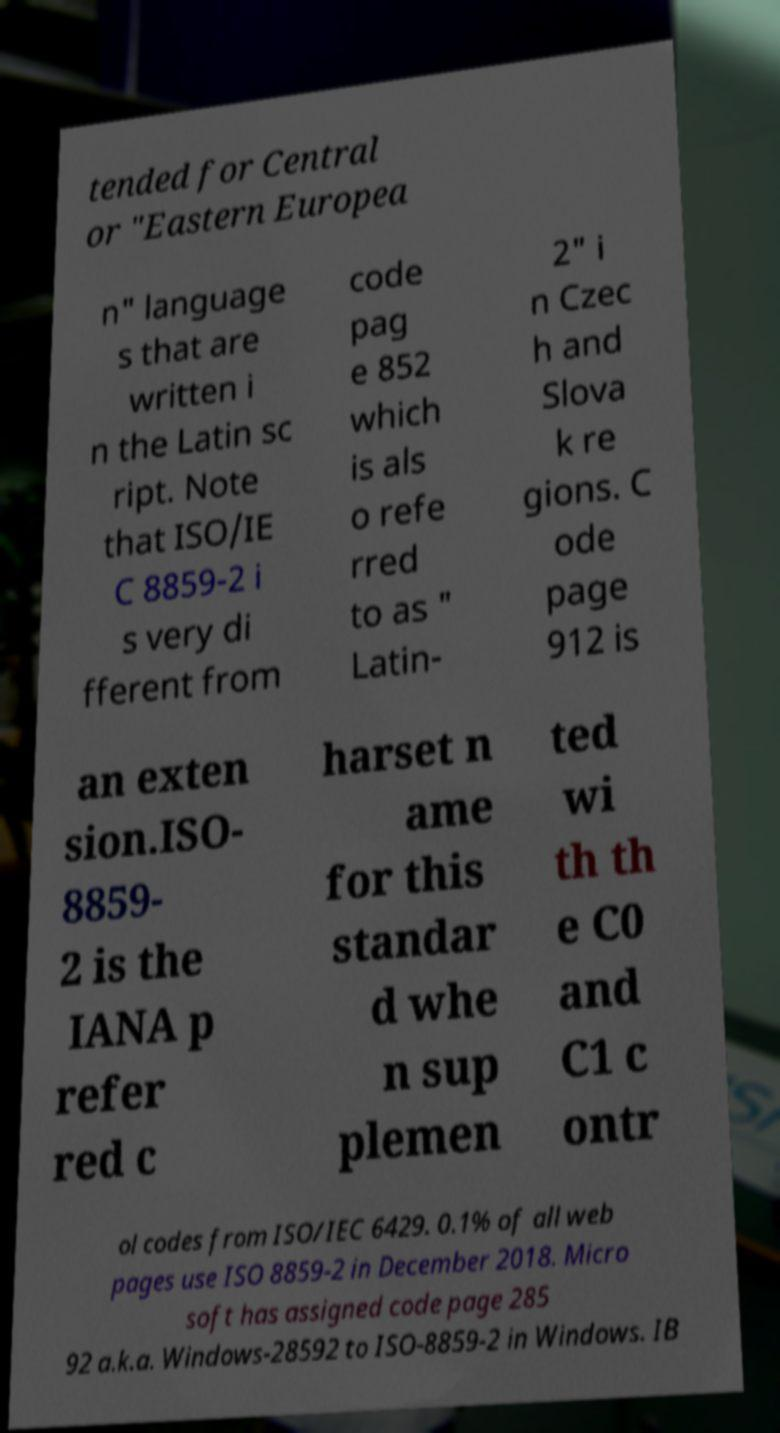Can you accurately transcribe the text from the provided image for me? tended for Central or "Eastern Europea n" language s that are written i n the Latin sc ript. Note that ISO/IE C 8859-2 i s very di fferent from code pag e 852 which is als o refe rred to as " Latin- 2" i n Czec h and Slova k re gions. C ode page 912 is an exten sion.ISO- 8859- 2 is the IANA p refer red c harset n ame for this standar d whe n sup plemen ted wi th th e C0 and C1 c ontr ol codes from ISO/IEC 6429. 0.1% of all web pages use ISO 8859-2 in December 2018. Micro soft has assigned code page 285 92 a.k.a. Windows-28592 to ISO-8859-2 in Windows. IB 